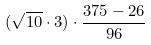<formula> <loc_0><loc_0><loc_500><loc_500>( \sqrt { 1 0 } \cdot 3 ) \cdot \frac { 3 7 5 - 2 6 } { 9 6 }</formula> 